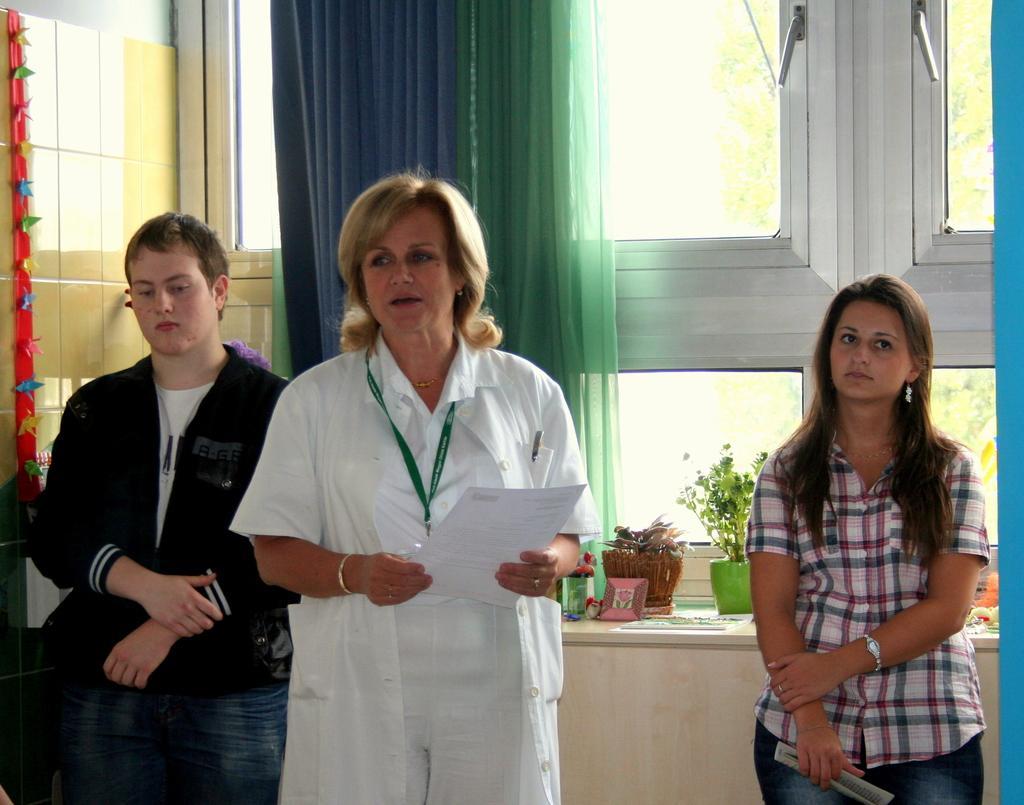How would you summarize this image in a sentence or two? In the picture I can see a woman wearing a shirt is standing on the right side of the image and a person wearing black color jacket is standing on the left side of the image and here we can see this person wearing a white color dress is holding a paper in her hands is standing at the center of the image. In the background, I can see flower pots and a few more objects are placed on the table and I can see the curtains and the glass windows. 